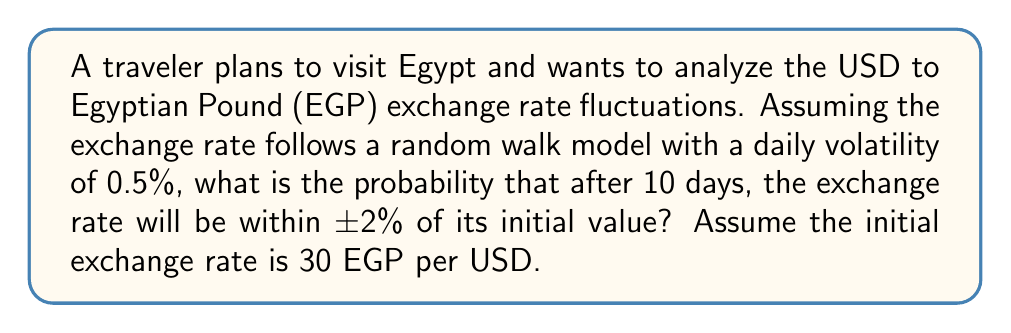Can you solve this math problem? Let's approach this step-by-step:

1) In a random walk model, the exchange rate changes are normally distributed with mean 0 and standard deviation $\sigma\sqrt{t}$, where $\sigma$ is the daily volatility and $t$ is the number of days.

2) Given:
   - Daily volatility $\sigma = 0.5\% = 0.005$
   - Time period $t = 10$ days
   - We want to find the probability of being within ±2% of the initial value

3) The standard deviation after 10 days is:
   $$\sigma\sqrt{t} = 0.005\sqrt{10} \approx 0.0158 = 1.58\%$$

4) We want to find the probability of being within ±2% of the initial value. This is equivalent to finding the probability of a standard normal random variable being between $-\frac{2\%}{1.58\%}$ and $\frac{2\%}{1.58\%}$.

5) Let's calculate these z-scores:
   $$z = \pm\frac{0.02}{0.0158} \approx \pm1.2658$$

6) Now, we need to find:
   $$P(-1.2658 < Z < 1.2658)$$
   where $Z$ is a standard normal random variable.

7) Using the standard normal distribution table or a calculator:
   $$P(Z < 1.2658) - P(Z < -1.2658) = 0.8972 - 0.1028 = 0.7944$$

Therefore, the probability that the exchange rate will be within ±2% of its initial value after 10 days is approximately 0.7944 or 79.44%.
Answer: 0.7944 